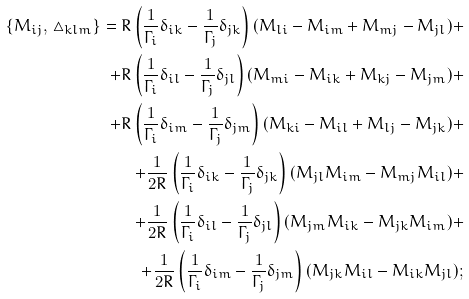Convert formula to latex. <formula><loc_0><loc_0><loc_500><loc_500>\{ M _ { i j } , \, \triangle _ { k l m } \} = R \left ( \frac { 1 } { \Gamma _ { i } } \delta _ { i k } - \frac { 1 } { \Gamma _ { j } } \delta _ { j k } \right ) ( M _ { l i } - M _ { i m } + M _ { m j } - M _ { j l } ) + \\ + R \left ( \frac { 1 } { \Gamma _ { i } } \delta _ { i l } - \frac { 1 } { \Gamma _ { j } } \delta _ { j l } \right ) ( M _ { m i } - M _ { i k } + M _ { k j } - M _ { j m } ) + \\ + R \left ( \frac { 1 } { \Gamma _ { i } } \delta _ { i m } - \frac { 1 } { \Gamma _ { j } } \delta _ { j m } \right ) ( M _ { k i } - M _ { i l } + M _ { l j } - M _ { j k } ) + \\ + \frac { 1 } { 2 R } \left ( \frac { 1 } { \Gamma _ { i } } \delta _ { i k } - \frac { 1 } { \Gamma _ { j } } \delta _ { j k } \right ) ( M _ { j l } M _ { i m } - M _ { m j } M _ { i l } ) + \\ + \frac { 1 } { 2 R } \left ( \frac { 1 } { \Gamma _ { i } } \delta _ { i l } - \frac { 1 } { \Gamma _ { j } } \delta _ { j l } \right ) ( M _ { j m } M _ { i k } - M _ { j k } M _ { i m } ) + \\ + \frac { 1 } { 2 R } \left ( \frac { 1 } { \Gamma _ { i } } \delta _ { i m } - \frac { 1 } { \Gamma _ { j } } \delta _ { j m } \right ) ( M _ { j k } M _ { i l } - M _ { i k } M _ { j l } ) ;</formula> 